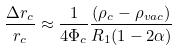Convert formula to latex. <formula><loc_0><loc_0><loc_500><loc_500>\frac { \Delta r _ { c } } { r _ { c } } \approx \frac { 1 } { 4 \Phi _ { c } } \frac { ( \rho _ { c } - \rho _ { v a c } ) } { R _ { 1 } ( 1 - 2 \alpha ) }</formula> 